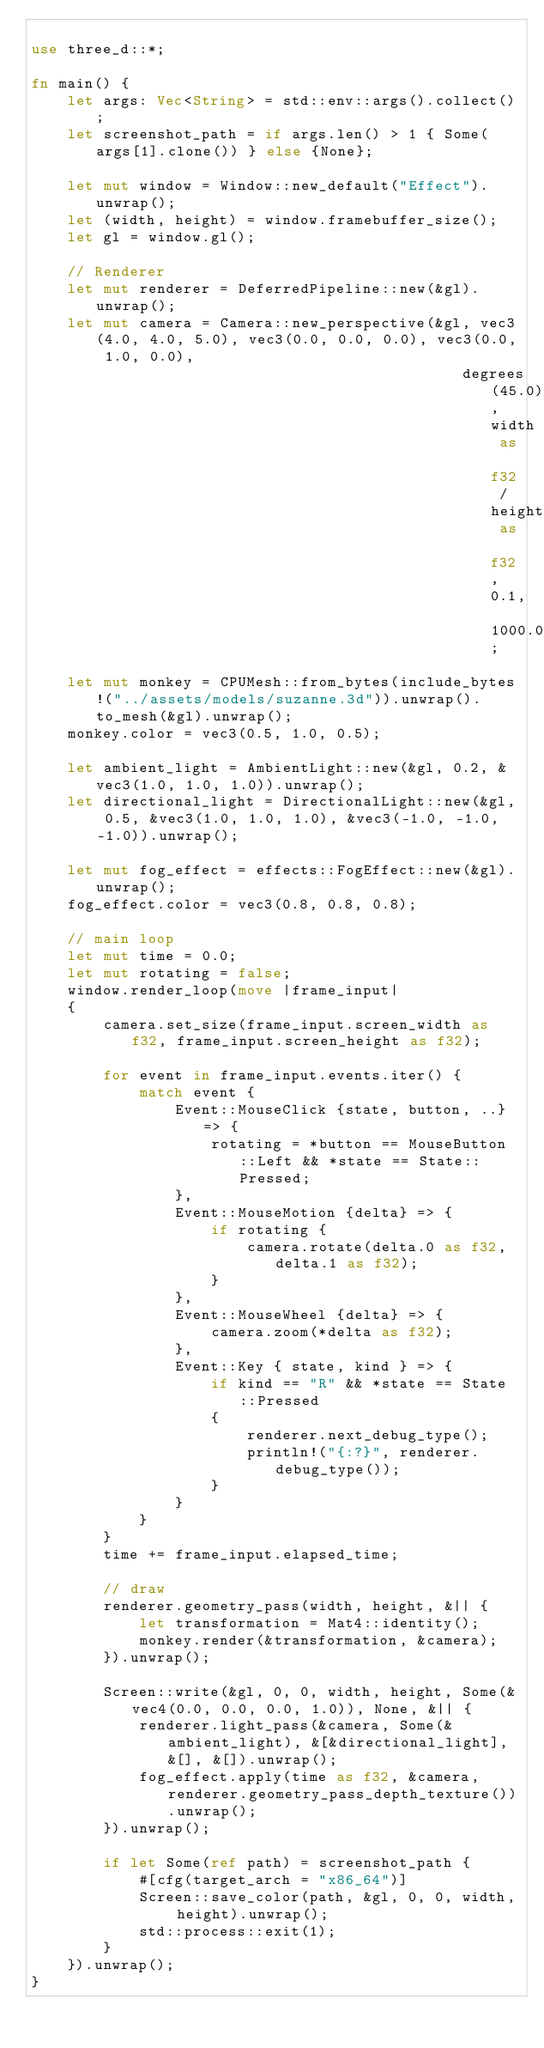Convert code to text. <code><loc_0><loc_0><loc_500><loc_500><_Rust_>
use three_d::*;

fn main() {
    let args: Vec<String> = std::env::args().collect();
    let screenshot_path = if args.len() > 1 { Some(args[1].clone()) } else {None};

    let mut window = Window::new_default("Effect").unwrap();
    let (width, height) = window.framebuffer_size();
    let gl = window.gl();

    // Renderer
    let mut renderer = DeferredPipeline::new(&gl).unwrap();
    let mut camera = Camera::new_perspective(&gl, vec3(4.0, 4.0, 5.0), vec3(0.0, 0.0, 0.0), vec3(0.0, 1.0, 0.0),
                                                degrees(45.0), width as f32 / height as f32, 0.1, 1000.0);

    let mut monkey = CPUMesh::from_bytes(include_bytes!("../assets/models/suzanne.3d")).unwrap().to_mesh(&gl).unwrap();
    monkey.color = vec3(0.5, 1.0, 0.5);

    let ambient_light = AmbientLight::new(&gl, 0.2, &vec3(1.0, 1.0, 1.0)).unwrap();
    let directional_light = DirectionalLight::new(&gl, 0.5, &vec3(1.0, 1.0, 1.0), &vec3(-1.0, -1.0, -1.0)).unwrap();

    let mut fog_effect = effects::FogEffect::new(&gl).unwrap();
    fog_effect.color = vec3(0.8, 0.8, 0.8);

    // main loop
    let mut time = 0.0;
    let mut rotating = false;
    window.render_loop(move |frame_input|
    {
        camera.set_size(frame_input.screen_width as f32, frame_input.screen_height as f32);

        for event in frame_input.events.iter() {
            match event {
                Event::MouseClick {state, button, ..} => {
                    rotating = *button == MouseButton::Left && *state == State::Pressed;
                },
                Event::MouseMotion {delta} => {
                    if rotating {
                        camera.rotate(delta.0 as f32, delta.1 as f32);
                    }
                },
                Event::MouseWheel {delta} => {
                    camera.zoom(*delta as f32);
                },
                Event::Key { state, kind } => {
                    if kind == "R" && *state == State::Pressed
                    {
                        renderer.next_debug_type();
                        println!("{:?}", renderer.debug_type());
                    }
                }
            }
        }
        time += frame_input.elapsed_time;

        // draw
        renderer.geometry_pass(width, height, &|| {
            let transformation = Mat4::identity();
            monkey.render(&transformation, &camera);
        }).unwrap();

        Screen::write(&gl, 0, 0, width, height, Some(&vec4(0.0, 0.0, 0.0, 1.0)), None, &|| {
            renderer.light_pass(&camera, Some(&ambient_light), &[&directional_light], &[], &[]).unwrap();
            fog_effect.apply(time as f32, &camera, renderer.geometry_pass_depth_texture()).unwrap();
        }).unwrap();

        if let Some(ref path) = screenshot_path {
            #[cfg(target_arch = "x86_64")]
            Screen::save_color(path, &gl, 0, 0, width, height).unwrap();
            std::process::exit(1);
        }
    }).unwrap();
}</code> 